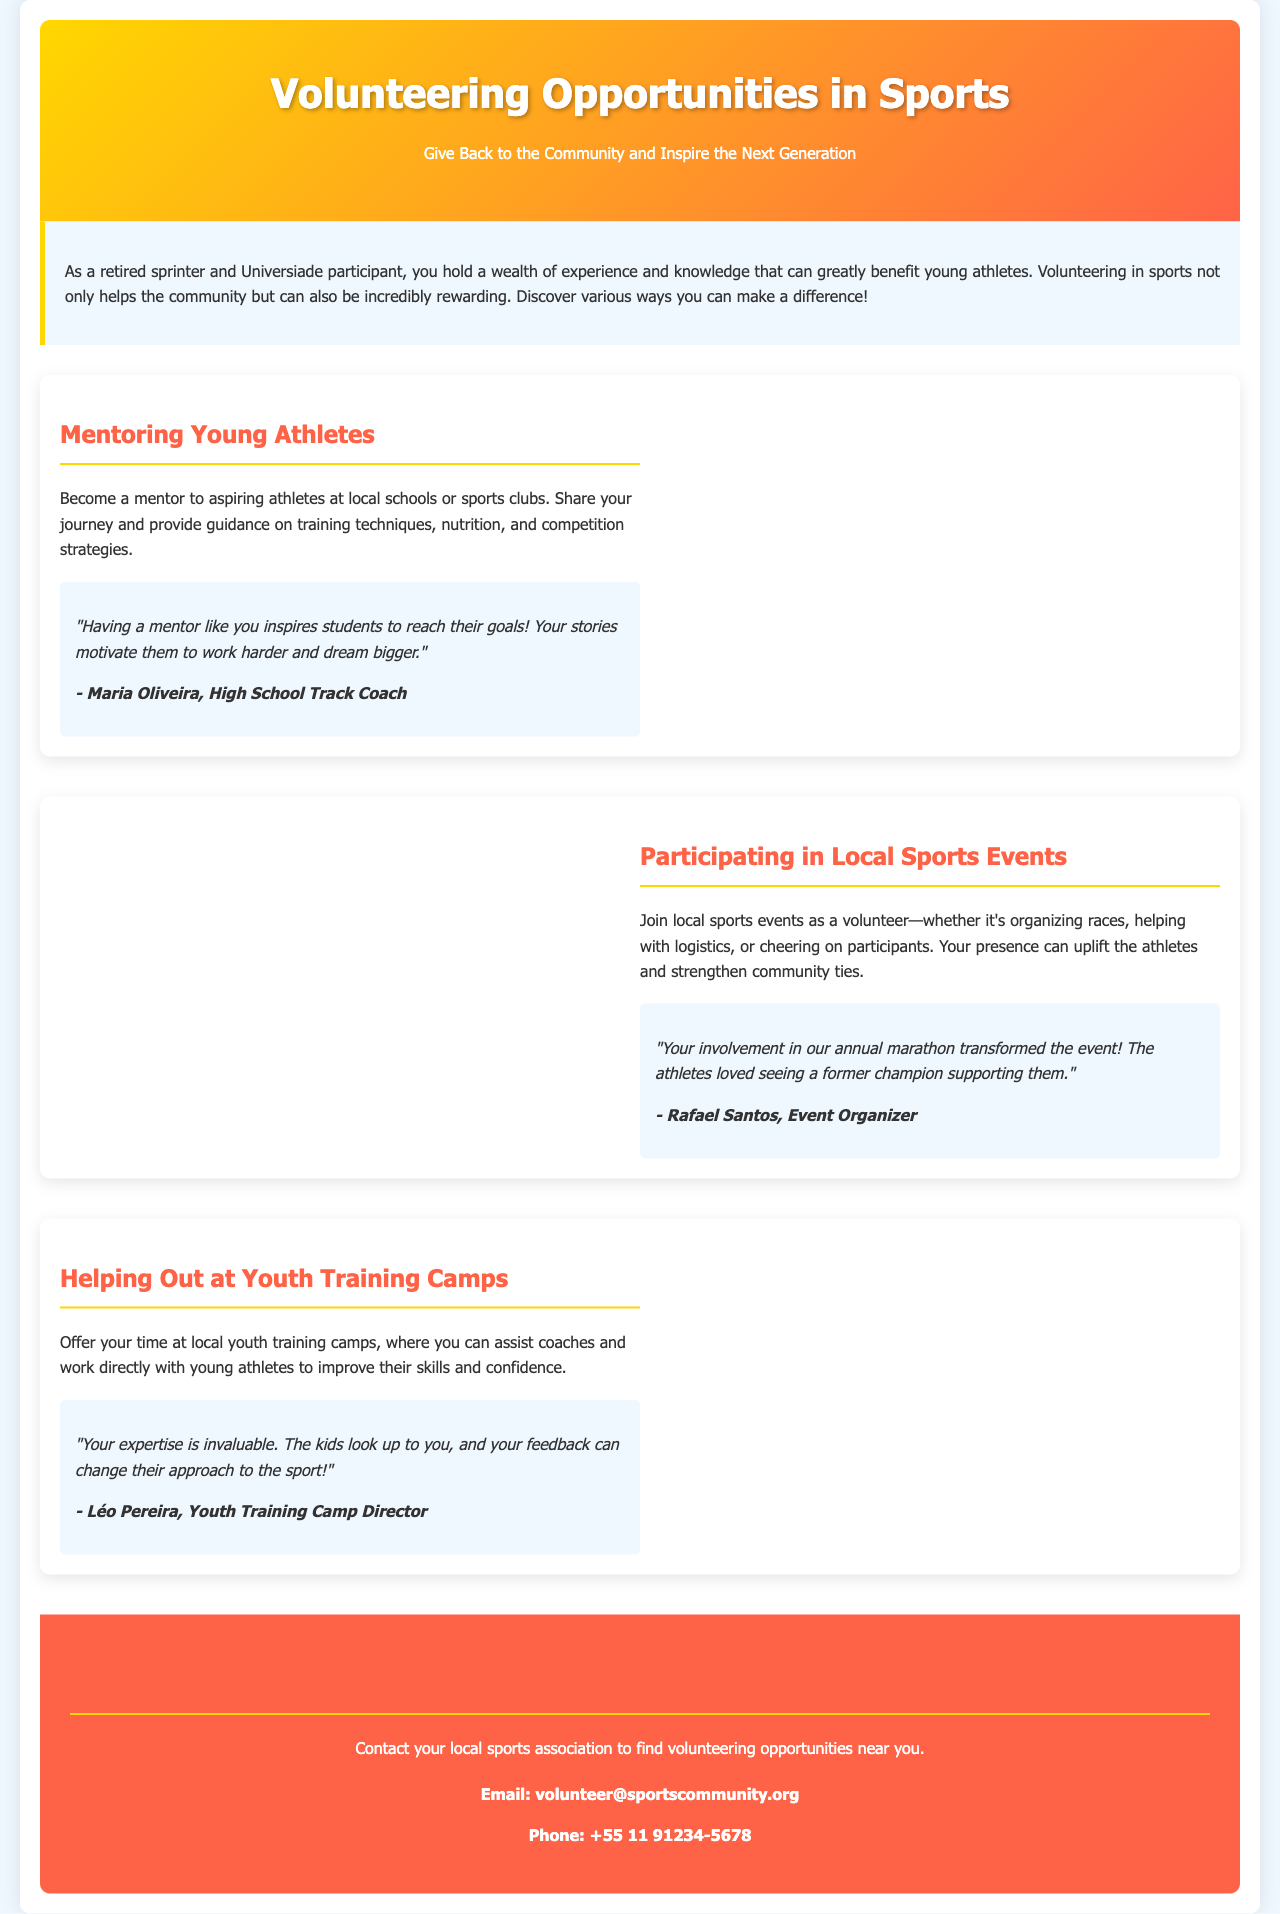what is the main title of the brochure? The main title of the brochure is displayed prominently at the top of the document.
Answer: Volunteering Opportunities in Sports what is a suggested way to volunteer according to the brochure? The brochure lists various ways to give back to the community.
Answer: Mentoring Young Athletes who provided a testimonial about mentoring? The testimonial is attributed to a specific person in the document.
Answer: Maria Oliveira what is the contact email for volunteer opportunities? The contact information for volunteering is provided at the end of the brochure.
Answer: volunteer@sportscommunity.org how many sections are there in the document about volunteering? The document contains specific sections that provide different volunteering opportunities.
Answer: Three what role does Léo Pereira have? Léo Pereira’s position related to volunteering is mentioned in a testimonial.
Answer: Youth Training Camp Director why is the involvement of volunteers seen as valuable? The brochure highlights the impact that volunteers have on the community and athletes.
Answer: It inspires and uplifts younger athletes what colors are used in the header? The color scheme of the header is distinct and intentional in the design.
Answer: Gold and red what activity takes place at local events? The brochure describes activities that volunteers might participate in at events.
Answer: Organizing races 